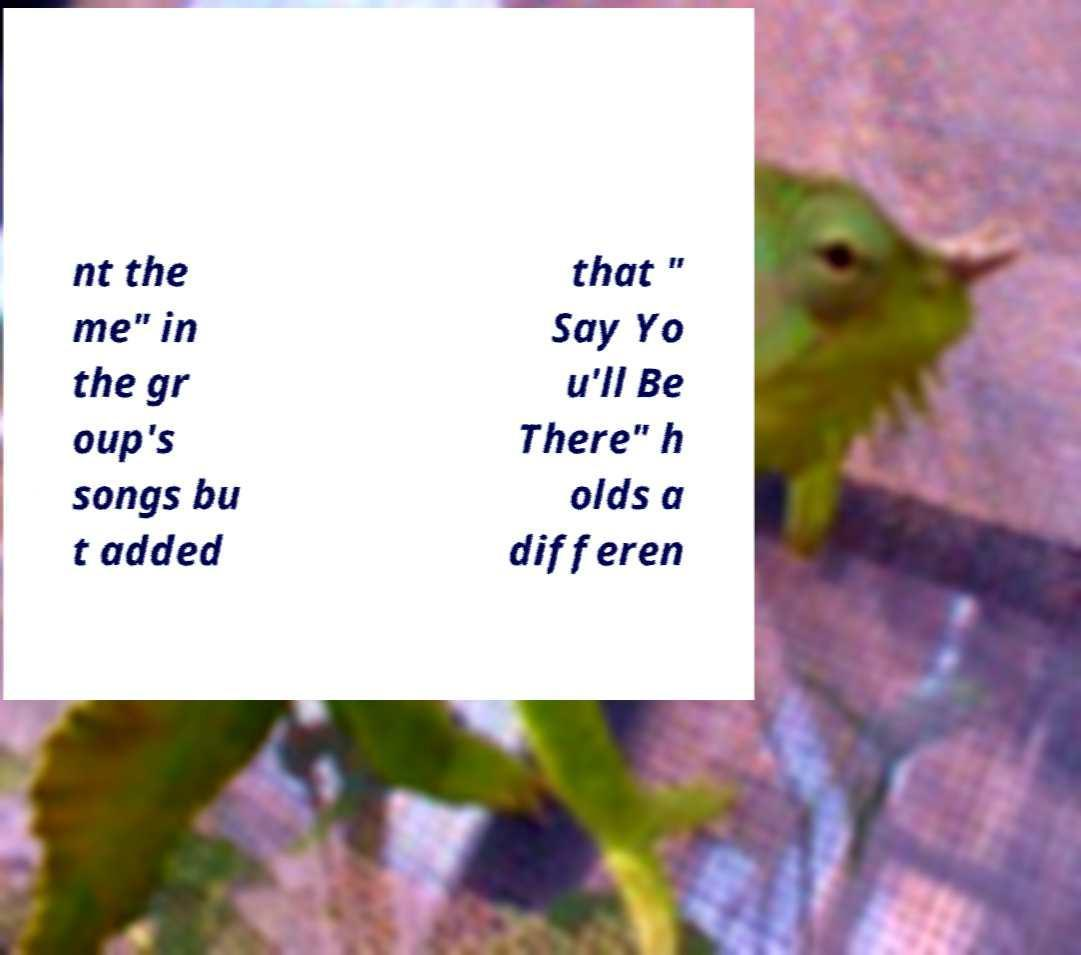Could you extract and type out the text from this image? nt the me" in the gr oup's songs bu t added that " Say Yo u'll Be There" h olds a differen 